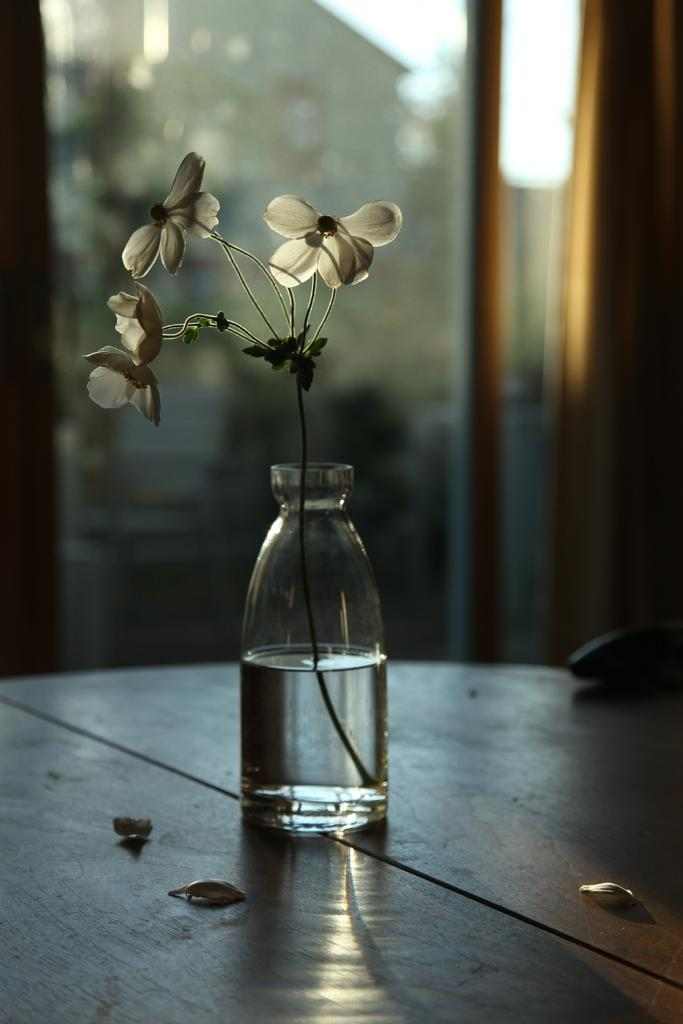What piece of furniture is present in the image? There is a table in the image. What object is placed on the table? There is a glass on the table. What is inside the glass? The glass contains water. What type of plant is visible in the image? There is a flower plant in the image. How is the flower plant contained? The flower plant is kept in a bottle. What type of trade is being conducted in the image? There is no trade being conducted in the image; it features a table with a glass of water and a flower plant in a bottle. Are there any masks visible in the image? There are no masks present in the image. 